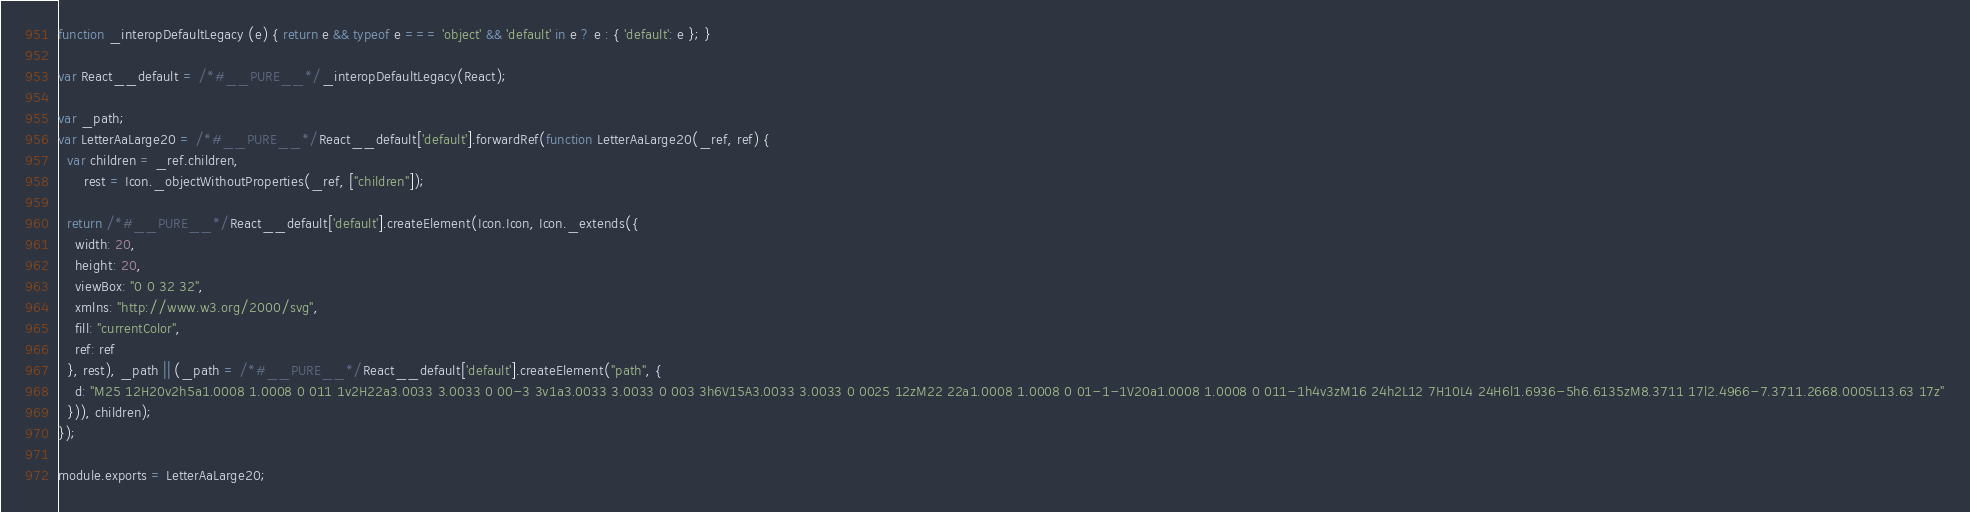Convert code to text. <code><loc_0><loc_0><loc_500><loc_500><_JavaScript_>
function _interopDefaultLegacy (e) { return e && typeof e === 'object' && 'default' in e ? e : { 'default': e }; }

var React__default = /*#__PURE__*/_interopDefaultLegacy(React);

var _path;
var LetterAaLarge20 = /*#__PURE__*/React__default['default'].forwardRef(function LetterAaLarge20(_ref, ref) {
  var children = _ref.children,
      rest = Icon._objectWithoutProperties(_ref, ["children"]);

  return /*#__PURE__*/React__default['default'].createElement(Icon.Icon, Icon._extends({
    width: 20,
    height: 20,
    viewBox: "0 0 32 32",
    xmlns: "http://www.w3.org/2000/svg",
    fill: "currentColor",
    ref: ref
  }, rest), _path || (_path = /*#__PURE__*/React__default['default'].createElement("path", {
    d: "M25 12H20v2h5a1.0008 1.0008 0 011 1v2H22a3.0033 3.0033 0 00-3 3v1a3.0033 3.0033 0 003 3h6V15A3.0033 3.0033 0 0025 12zM22 22a1.0008 1.0008 0 01-1-1V20a1.0008 1.0008 0 011-1h4v3zM16 24h2L12 7H10L4 24H6l1.6936-5h6.6135zM8.3711 17l2.4966-7.3711.2668.0005L13.63 17z"
  })), children);
});

module.exports = LetterAaLarge20;
</code> 